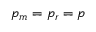<formula> <loc_0><loc_0><loc_500><loc_500>p _ { m } = p _ { r } = p</formula> 